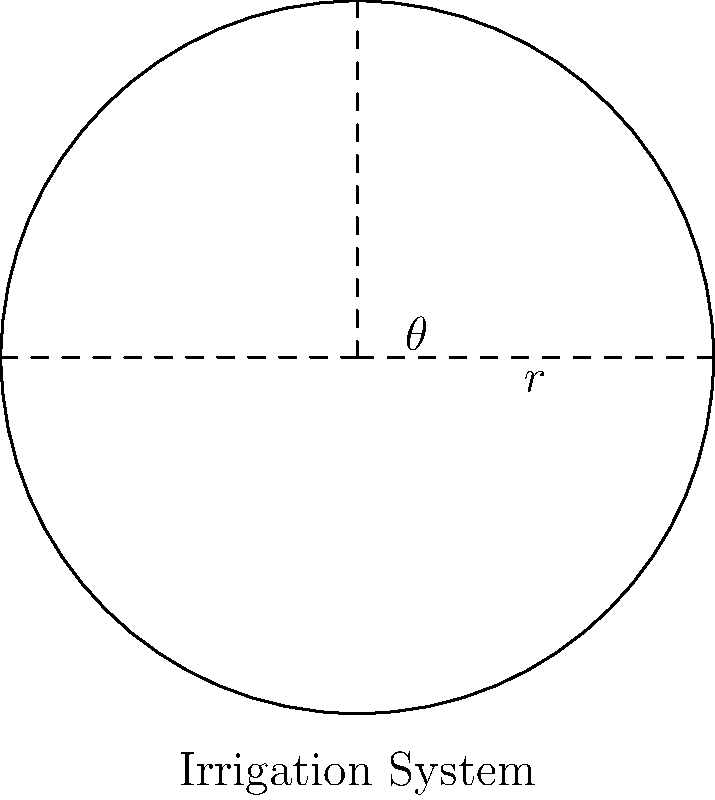In a circular irrigation system for a vineyard, the sprinkler arm rotates through an angle of $60°$. If the arm has a length of 30 meters, what is the area of the vineyard section covered by this irrigation system? Round your answer to the nearest square meter. To solve this problem, we'll follow these steps:

1) The irrigation system creates a sector of a circle. We need to find the area of this sector.

2) The formula for the area of a sector is:
   $$A = \frac{\theta}{360°} \pi r^2$$
   where $\theta$ is the central angle in degrees and $r$ is the radius.

3) We're given:
   - $\theta = 60°$
   - $r = 30$ meters

4) Let's substitute these values into our formula:
   $$A = \frac{60°}{360°} \pi (30\text{m})^2$$

5) Simplify:
   $$A = \frac{1}{6} \pi (900\text{m}^2)$$
   $$A = 150\pi \text{ m}^2$$

6) Calculate and round to the nearest square meter:
   $$A \approx 471 \text{ m}^2$$

Therefore, the irrigation system covers approximately 471 square meters of the vineyard.
Answer: 471 m² 